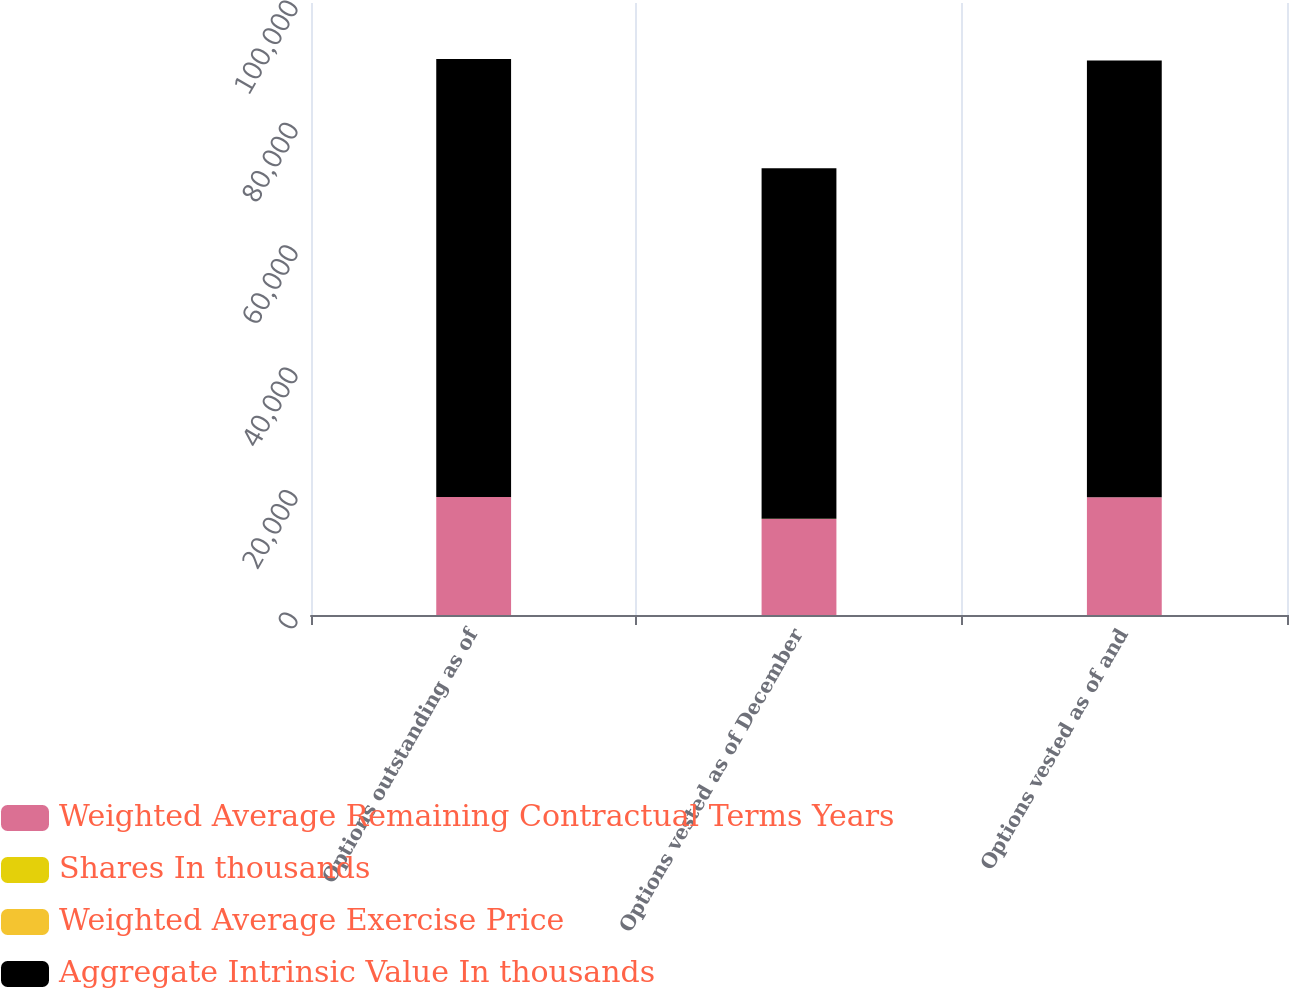Convert chart. <chart><loc_0><loc_0><loc_500><loc_500><stacked_bar_chart><ecel><fcel>Options outstanding as of<fcel>Options vested as of December<fcel>Options vested as of and<nl><fcel>Weighted Average Remaining Contractual Terms Years<fcel>19278<fcel>15696<fcel>19222<nl><fcel>Shares In thousands<fcel>10.71<fcel>11<fcel>10.71<nl><fcel>Weighted Average Exercise Price<fcel>3.4<fcel>2.9<fcel>3.3<nl><fcel>Aggregate Intrinsic Value In thousands<fcel>71574<fcel>57307<fcel>71386<nl></chart> 